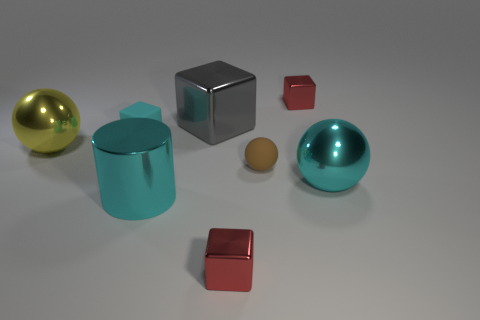Subtract all small brown matte balls. How many balls are left? 2 Subtract 1 gray blocks. How many objects are left? 7 Subtract all balls. How many objects are left? 5 Subtract 1 cubes. How many cubes are left? 3 Subtract all brown spheres. Subtract all yellow blocks. How many spheres are left? 2 Subtract all gray cylinders. How many gray cubes are left? 1 Subtract all small gray blocks. Subtract all small brown spheres. How many objects are left? 7 Add 8 tiny cyan rubber things. How many tiny cyan rubber things are left? 9 Add 3 large gray metallic balls. How many large gray metallic balls exist? 3 Add 2 red things. How many objects exist? 10 